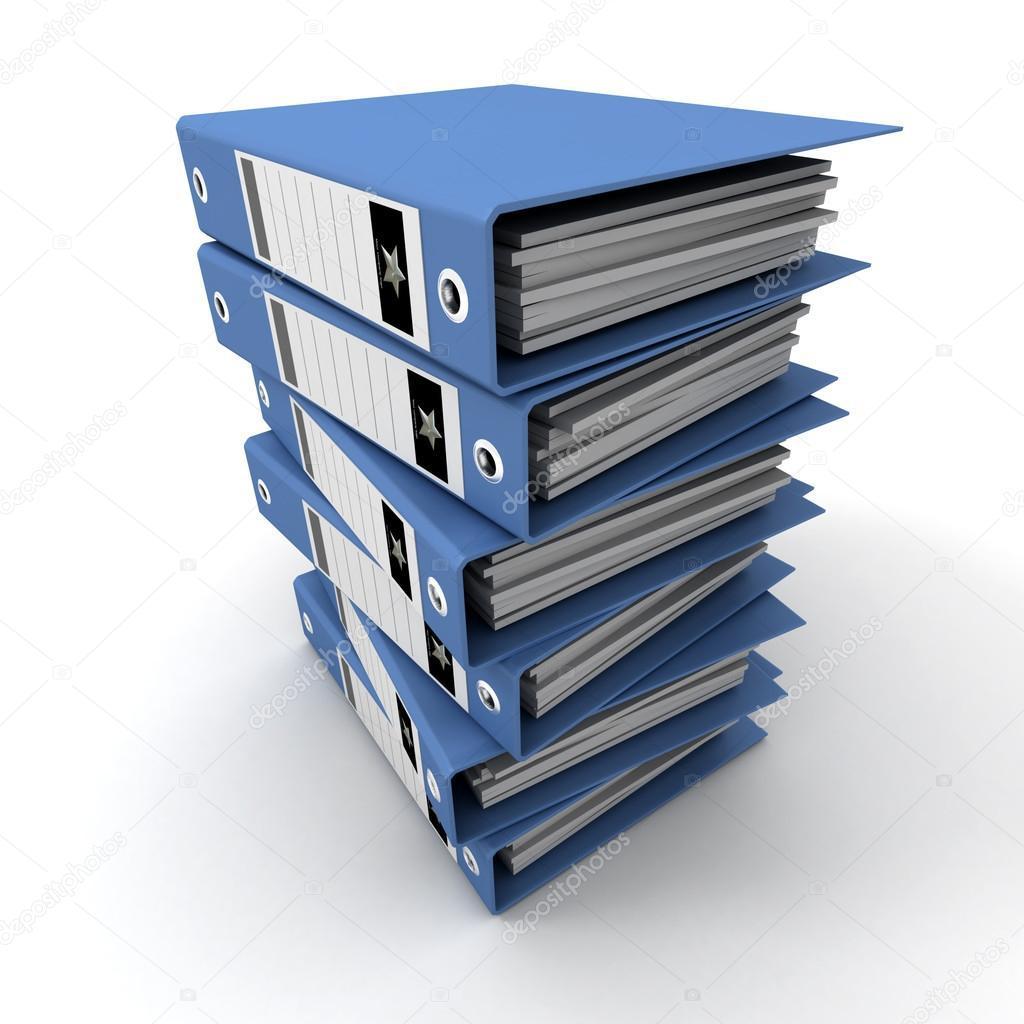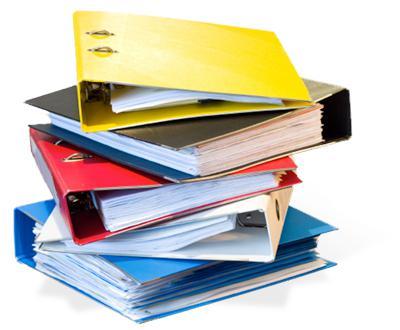The first image is the image on the left, the second image is the image on the right. Considering the images on both sides, is "There is a collection of red binders." valid? Answer yes or no. No. The first image is the image on the left, the second image is the image on the right. Evaluate the accuracy of this statement regarding the images: "In one image all the binders are red.". Is it true? Answer yes or no. No. 